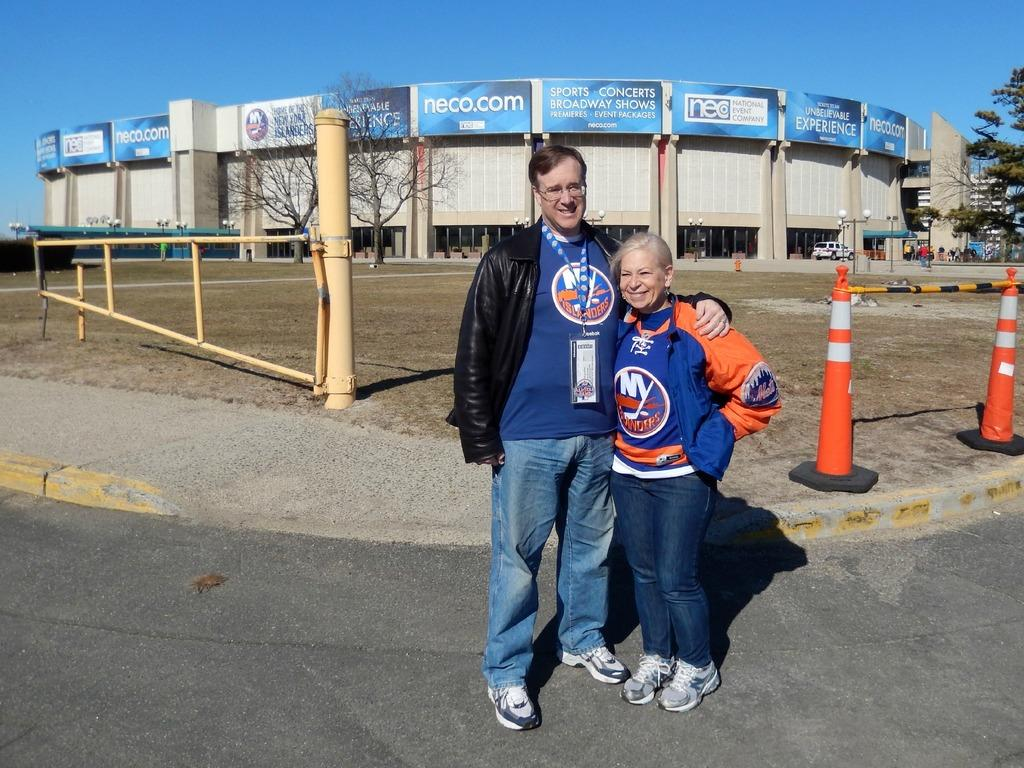<image>
Relay a brief, clear account of the picture shown. A man and a woman standing in front of the home Arena of the New York Islanders. 